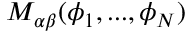Convert formula to latex. <formula><loc_0><loc_0><loc_500><loc_500>M _ { \alpha \beta } ( \phi _ { 1 } , \dots , \phi _ { N } )</formula> 